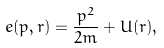<formula> <loc_0><loc_0><loc_500><loc_500>e ( p , r ) = \frac { p ^ { 2 } } { 2 m } + U ( r ) ,</formula> 